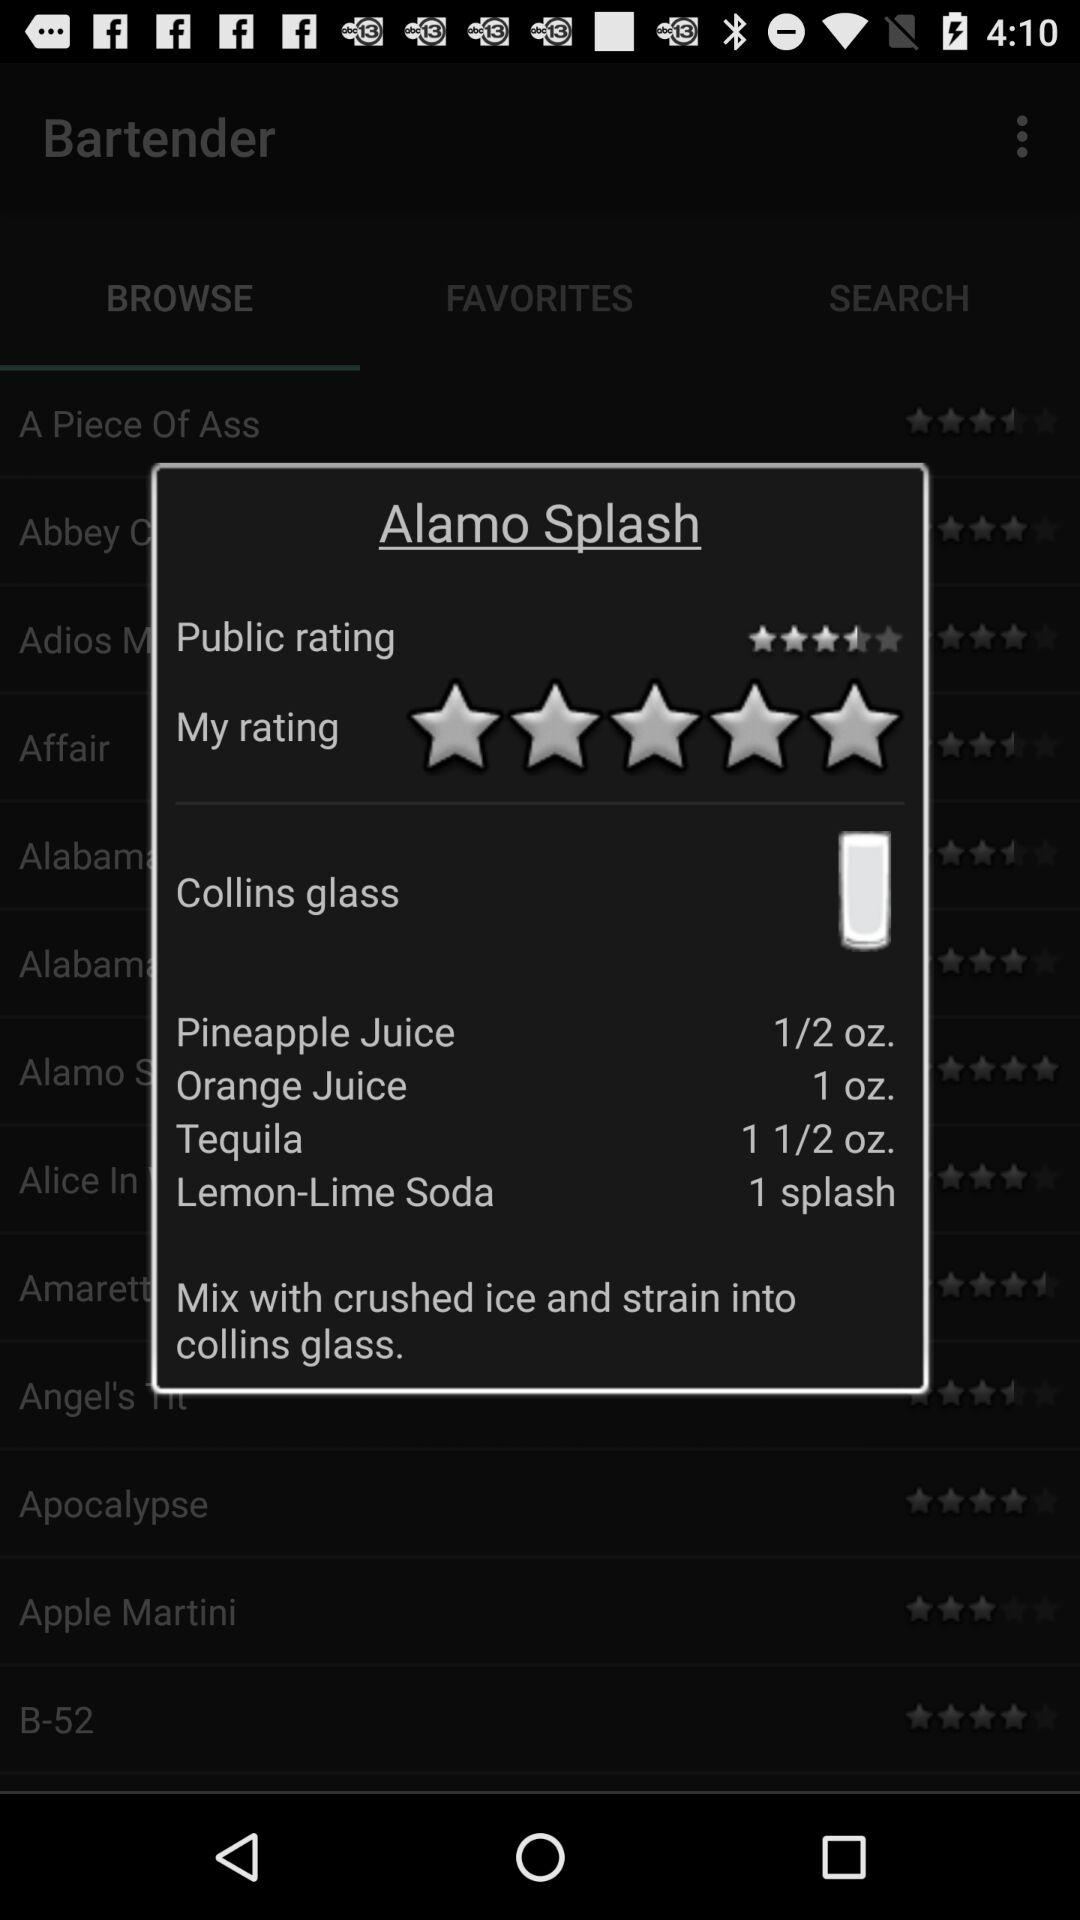What is the public rating of Alamo Splash? The public rating is 3.5 stars. 